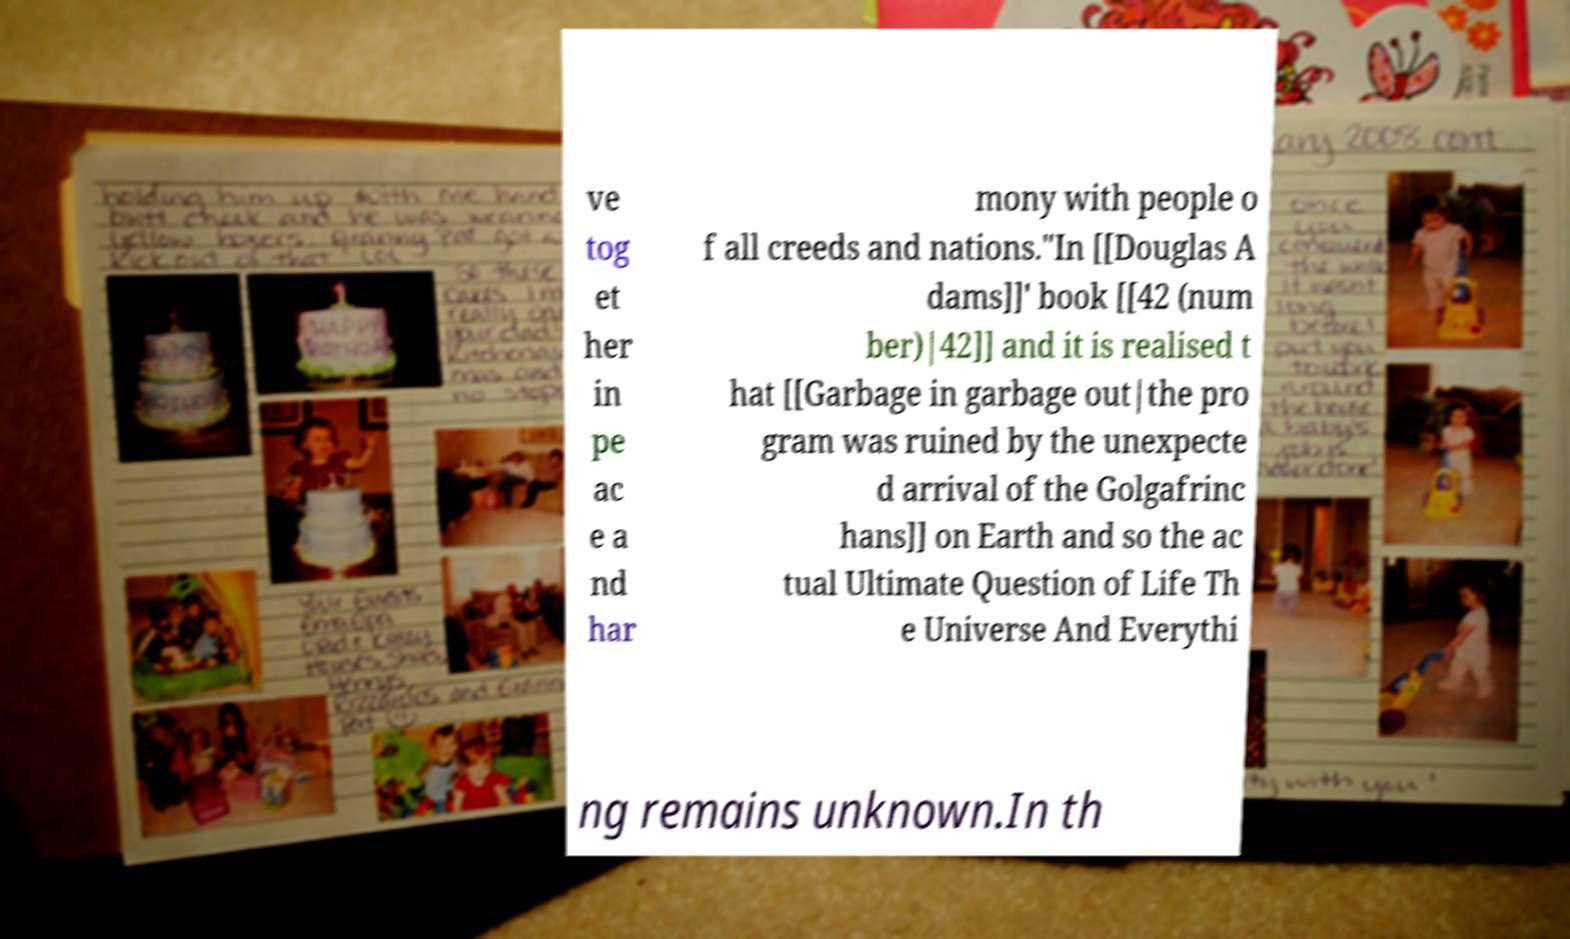Please identify and transcribe the text found in this image. ve tog et her in pe ac e a nd har mony with people o f all creeds and nations."In [[Douglas A dams]]' book [[42 (num ber)|42]] and it is realised t hat [[Garbage in garbage out|the pro gram was ruined by the unexpecte d arrival of the Golgafrinc hans]] on Earth and so the ac tual Ultimate Question of Life Th e Universe And Everythi ng remains unknown.In th 